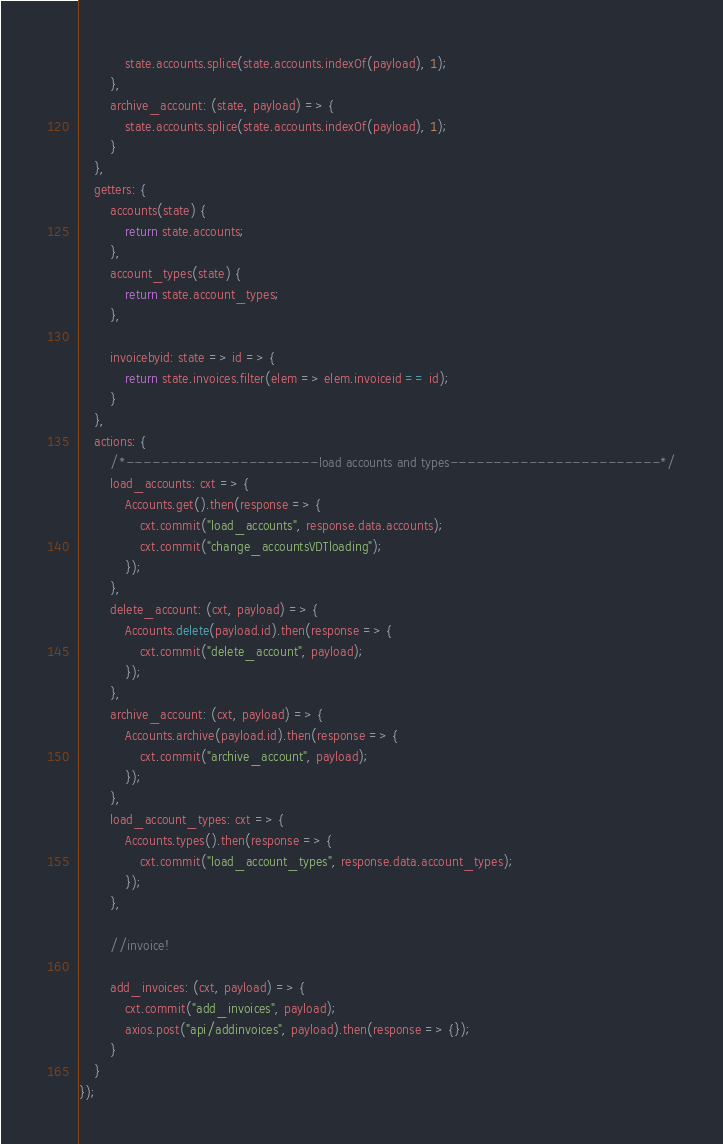<code> <loc_0><loc_0><loc_500><loc_500><_JavaScript_>            state.accounts.splice(state.accounts.indexOf(payload), 1);
        },
        archive_account: (state, payload) => {
            state.accounts.splice(state.accounts.indexOf(payload), 1);
        }
    },
    getters: {
        accounts(state) {
            return state.accounts;
        },
        account_types(state) {
            return state.account_types;
        },

        invoicebyid: state => id => {
            return state.invoices.filter(elem => elem.invoiceid == id);
        }
    },
    actions: {
        /*----------------------load accounts and types------------------------*/
        load_accounts: cxt => {
            Accounts.get().then(response => {
                cxt.commit("load_accounts", response.data.accounts);
                cxt.commit("change_accountsVDTloading");
            });
        },
        delete_account: (cxt, payload) => {
            Accounts.delete(payload.id).then(response => {
                cxt.commit("delete_account", payload);
            });
        },
        archive_account: (cxt, payload) => {
            Accounts.archive(payload.id).then(response => {
                cxt.commit("archive_account", payload);
            });
        },
        load_account_types: cxt => {
            Accounts.types().then(response => {
                cxt.commit("load_account_types", response.data.account_types);
            });
        },

        //invoice!

        add_invoices: (cxt, payload) => {
            cxt.commit("add_invoices", payload);
            axios.post("api/addinvoices", payload).then(response => {});
        }
    }
});</code> 